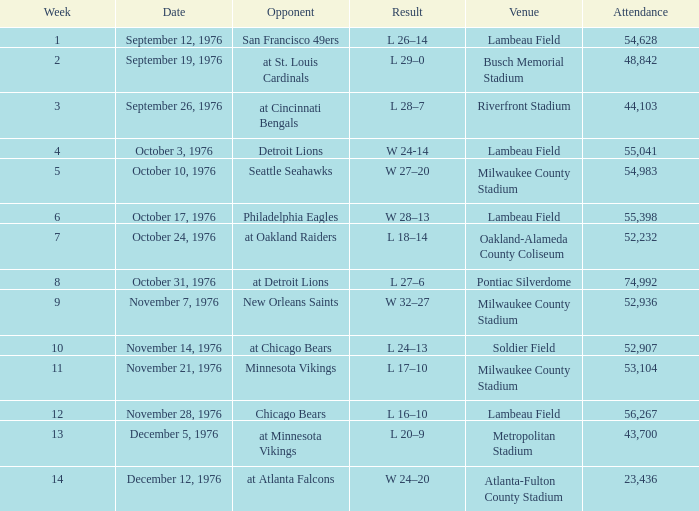How many people attended the game on September 19, 1976? 1.0. 